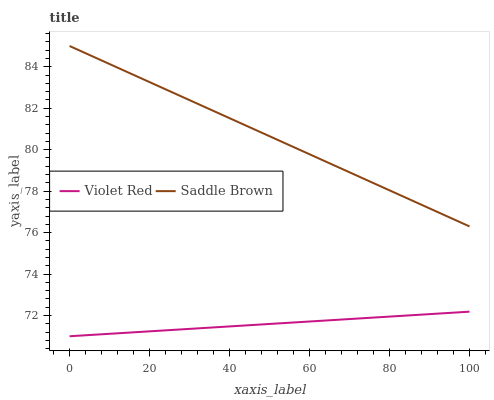Does Violet Red have the minimum area under the curve?
Answer yes or no. Yes. Does Saddle Brown have the maximum area under the curve?
Answer yes or no. Yes. Does Saddle Brown have the minimum area under the curve?
Answer yes or no. No. Is Saddle Brown the smoothest?
Answer yes or no. Yes. Is Violet Red the roughest?
Answer yes or no. Yes. Is Saddle Brown the roughest?
Answer yes or no. No. Does Saddle Brown have the lowest value?
Answer yes or no. No. Does Saddle Brown have the highest value?
Answer yes or no. Yes. Is Violet Red less than Saddle Brown?
Answer yes or no. Yes. Is Saddle Brown greater than Violet Red?
Answer yes or no. Yes. Does Violet Red intersect Saddle Brown?
Answer yes or no. No. 